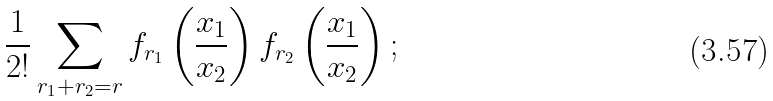Convert formula to latex. <formula><loc_0><loc_0><loc_500><loc_500>\frac { 1 } { 2 ! } \sum _ { r _ { 1 } + r _ { 2 } = r } f _ { r _ { 1 } } \left ( \frac { x _ { 1 } } { x _ { 2 } } \right ) f _ { r _ { 2 } } \left ( \frac { x _ { 1 } } { x _ { 2 } } \right ) ;</formula> 